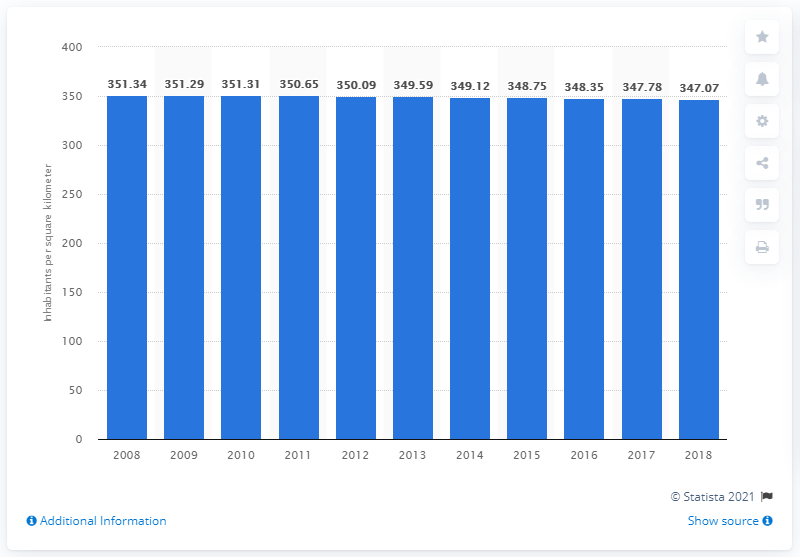Mention a couple of crucial points in this snapshot. In 2018, Japan had a population density of 347.07 people per square kilometer. 